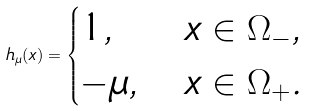Convert formula to latex. <formula><loc_0><loc_0><loc_500><loc_500>h _ { \mu } ( x ) = \begin{cases} 1 , & x \in \Omega _ { - } , \\ - \mu , & x \in \Omega _ { + } . \end{cases}</formula> 